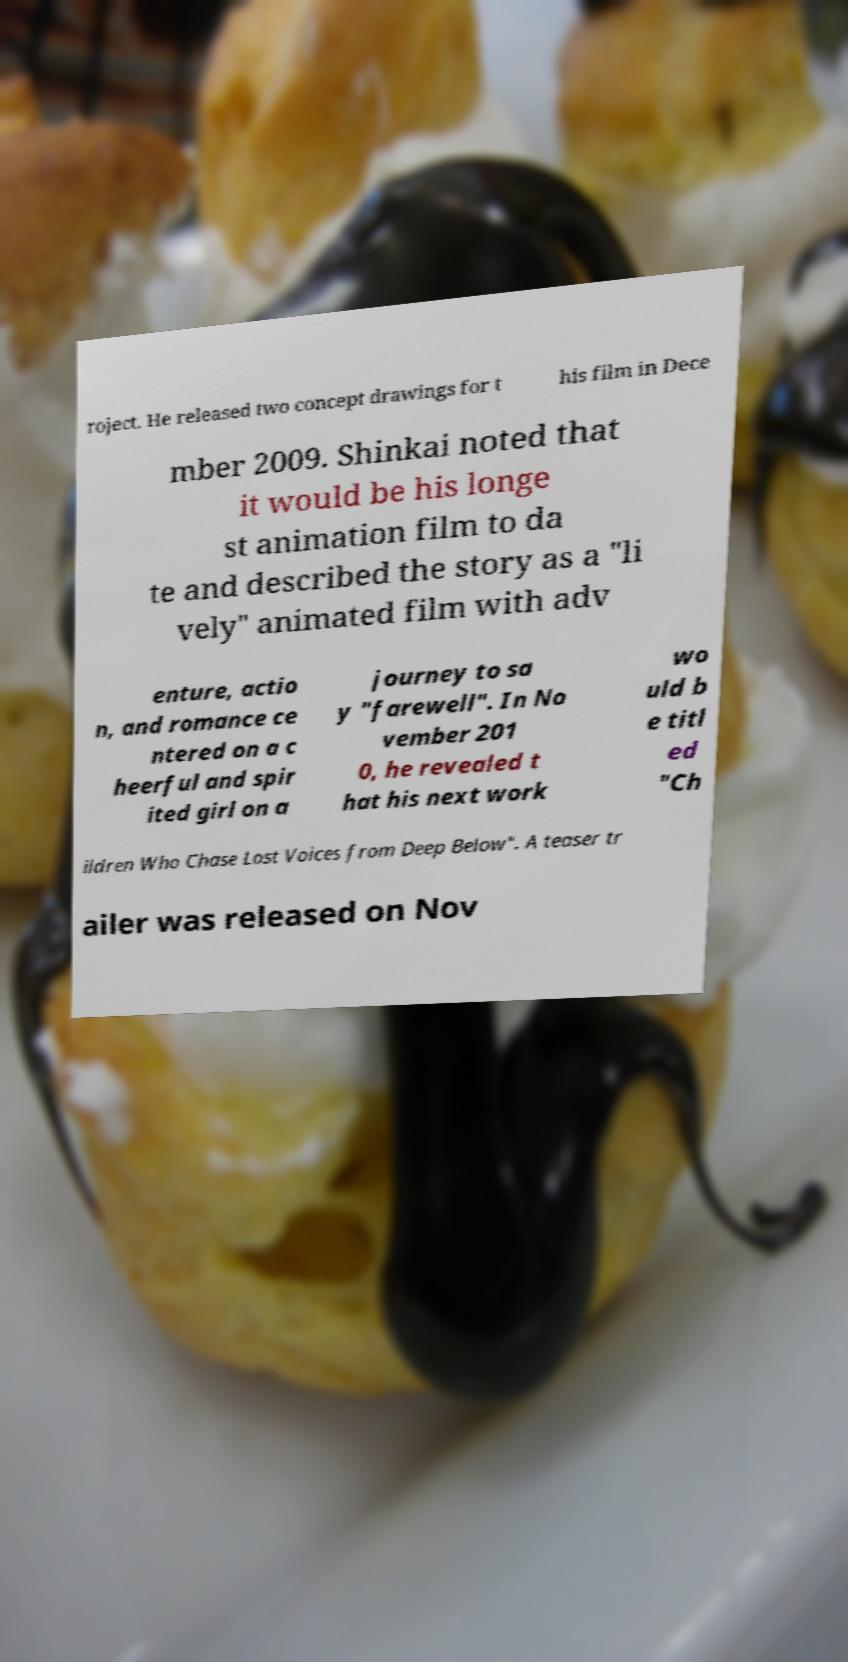Could you extract and type out the text from this image? roject. He released two concept drawings for t his film in Dece mber 2009. Shinkai noted that it would be his longe st animation film to da te and described the story as a "li vely" animated film with adv enture, actio n, and romance ce ntered on a c heerful and spir ited girl on a journey to sa y "farewell". In No vember 201 0, he revealed t hat his next work wo uld b e titl ed "Ch ildren Who Chase Lost Voices from Deep Below". A teaser tr ailer was released on Nov 